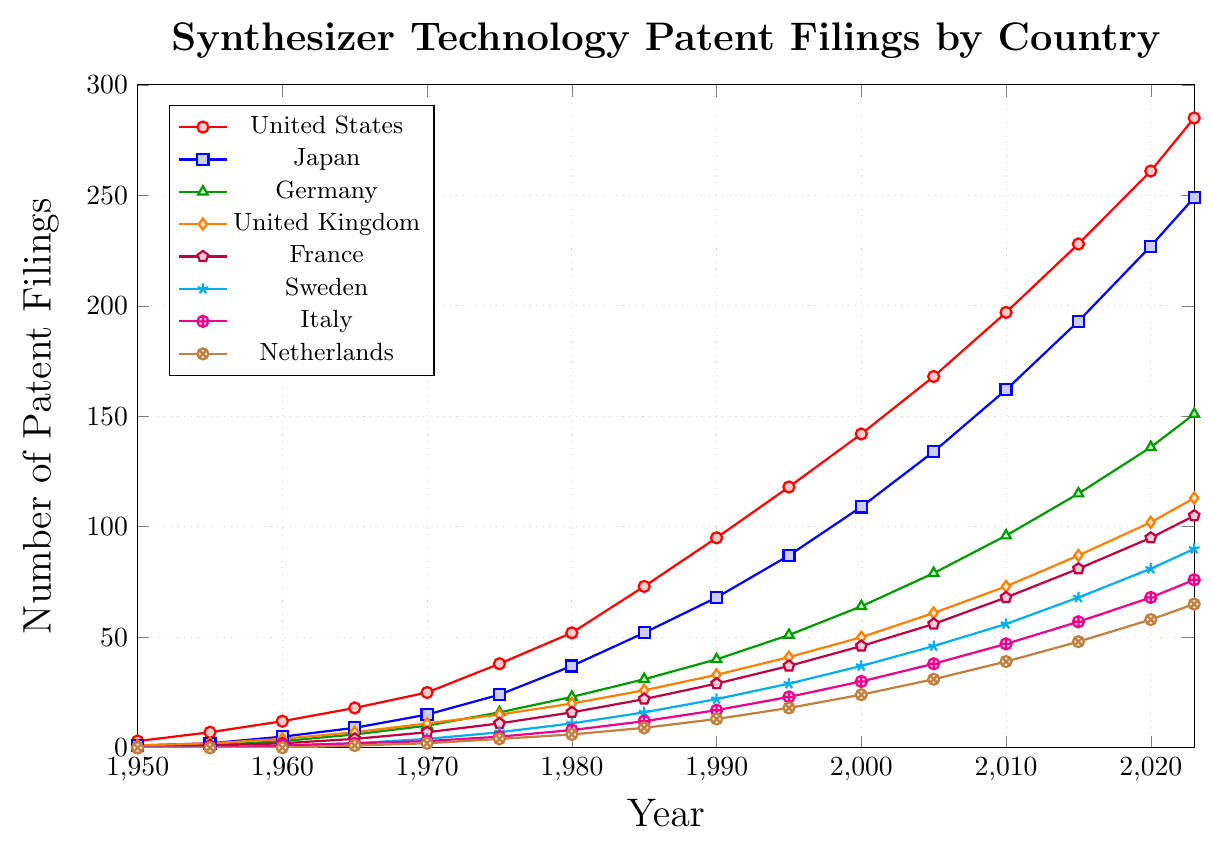What is the total number of patent filings in 2023 for the United States, Japan, and Germany combined? Sum the patent filings for the United States, Japan, and Germany for the year 2023: 285 (United States) + 249 (Japan) + 151 (Germany) = 685
Answer: 685 Which country had the second highest number of patent filings in 1980? Refer to the values for each country in 1980 and identify the one with the second highest number. The United States had the highest (52), followed by Japan (37).
Answer: Japan How many more patent filings were there in the United States compared to Italy in 2010? Subtract the number of patents filed in Italy from those filed in the United States in 2010: 197 (United States) - 47 (Italy) = 150
Answer: 150 What was the increase in patent filings in France from 1975 to 2023? Subtract the number of filings in France in 1975 from the number in 2023: 105 (2023) - 11 (1975) = 94
Answer: 94 Which country had the highest growth rate in patent filings between 1950 and 2023? Calculate the increase for each country and compare: United States increased by 282, Japan by 248, Germany by 151, United Kingdom by 112, France by 105, Sweden by 90, Italy by 76, and Netherlands by 65. The United States has the highest increase.
Answer: United States Which countries had more than 100 patent filings in 2015? Identify the countries with more than 100 filings in 2015: United States (228), Japan (193), Germany (115), United Kingdom (87), and France (81). Only the United States, Japan, and Germany fit the criteria.
Answer: United States, Japan, Germany How many countries had at least 20 patent filings by 1975? Check the data for 1975 and count the countries with at least 20 filings: United States (38), Japan (24), Germany (16), and United Kingdom (15). Only the United States and Japan had at least 20 filings by 1975.
Answer: 2 By how many filings did Sweden increase its number of patents from 1990 to 2020? Subtract the number of filings in 1990 from those in 2020 for Sweden: 81 (2020) - 22 (1990) = 59
Answer: 59 Which country saw the smallest number of patent filings in 1955? Look for the smallest number among the countries in 1955. Both Sweden and the Netherlands had 0 in 1955.
Answer: Sweden, Netherlands What is the average number of patent filings across all countries in 1990? Sum the number of filings in 1990 and divide by the number of countries: (95 + 68 + 40 + 33 + 29 + 22 + 17 + 13) / 8 = 39.625
Answer: 39.625 